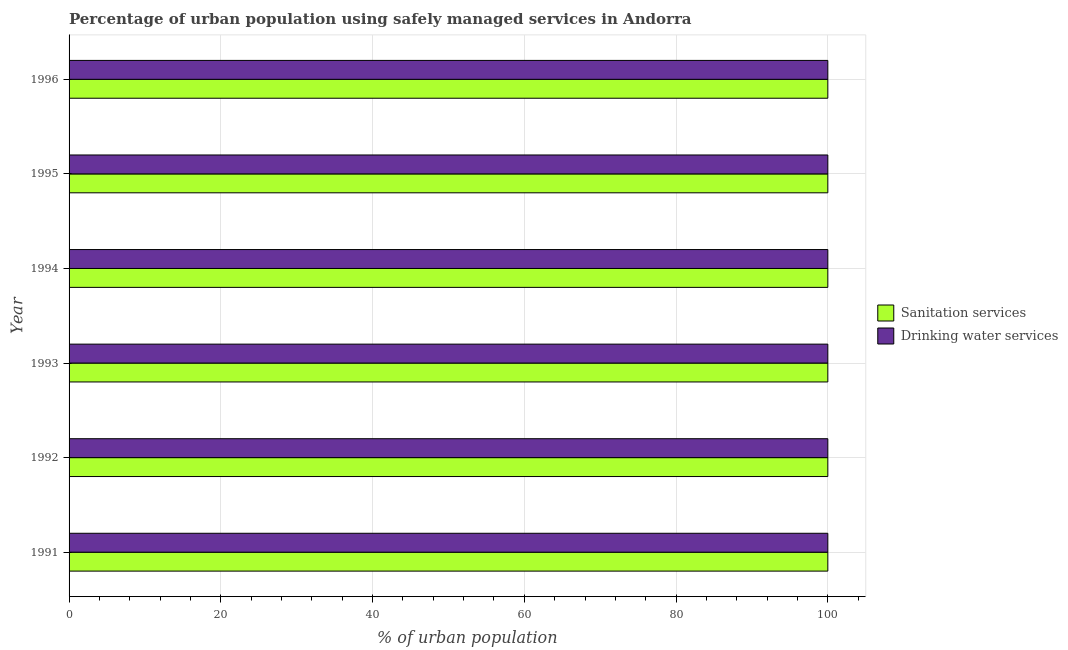How many different coloured bars are there?
Provide a succinct answer. 2. Are the number of bars per tick equal to the number of legend labels?
Provide a short and direct response. Yes. What is the percentage of urban population who used drinking water services in 1996?
Provide a short and direct response. 100. Across all years, what is the maximum percentage of urban population who used sanitation services?
Your answer should be compact. 100. Across all years, what is the minimum percentage of urban population who used sanitation services?
Keep it short and to the point. 100. What is the total percentage of urban population who used drinking water services in the graph?
Offer a very short reply. 600. What is the difference between the percentage of urban population who used drinking water services in 1994 and the percentage of urban population who used sanitation services in 1991?
Provide a short and direct response. 0. In how many years, is the percentage of urban population who used sanitation services greater than 76 %?
Make the answer very short. 6. Is the percentage of urban population who used sanitation services in 1991 less than that in 1994?
Your response must be concise. No. What is the difference between the highest and the second highest percentage of urban population who used drinking water services?
Give a very brief answer. 0. What is the difference between the highest and the lowest percentage of urban population who used sanitation services?
Offer a very short reply. 0. In how many years, is the percentage of urban population who used sanitation services greater than the average percentage of urban population who used sanitation services taken over all years?
Your answer should be compact. 0. Is the sum of the percentage of urban population who used drinking water services in 1992 and 1995 greater than the maximum percentage of urban population who used sanitation services across all years?
Keep it short and to the point. Yes. What does the 2nd bar from the top in 1993 represents?
Your answer should be very brief. Sanitation services. What does the 1st bar from the bottom in 1991 represents?
Keep it short and to the point. Sanitation services. How many bars are there?
Your answer should be compact. 12. Are all the bars in the graph horizontal?
Give a very brief answer. Yes. How many years are there in the graph?
Keep it short and to the point. 6. What is the difference between two consecutive major ticks on the X-axis?
Make the answer very short. 20. Does the graph contain grids?
Offer a terse response. Yes. How are the legend labels stacked?
Your answer should be compact. Vertical. What is the title of the graph?
Keep it short and to the point. Percentage of urban population using safely managed services in Andorra. Does "ODA received" appear as one of the legend labels in the graph?
Make the answer very short. No. What is the label or title of the X-axis?
Keep it short and to the point. % of urban population. What is the % of urban population in Sanitation services in 1992?
Offer a very short reply. 100. What is the % of urban population of Drinking water services in 1992?
Make the answer very short. 100. What is the % of urban population of Drinking water services in 1993?
Keep it short and to the point. 100. What is the % of urban population in Drinking water services in 1994?
Offer a terse response. 100. What is the % of urban population of Sanitation services in 1995?
Make the answer very short. 100. What is the % of urban population of Sanitation services in 1996?
Provide a succinct answer. 100. What is the % of urban population of Drinking water services in 1996?
Offer a very short reply. 100. Across all years, what is the maximum % of urban population in Sanitation services?
Make the answer very short. 100. Across all years, what is the maximum % of urban population of Drinking water services?
Keep it short and to the point. 100. What is the total % of urban population in Sanitation services in the graph?
Make the answer very short. 600. What is the total % of urban population of Drinking water services in the graph?
Your answer should be very brief. 600. What is the difference between the % of urban population of Sanitation services in 1991 and that in 1992?
Provide a short and direct response. 0. What is the difference between the % of urban population of Drinking water services in 1991 and that in 1992?
Provide a succinct answer. 0. What is the difference between the % of urban population in Sanitation services in 1991 and that in 1995?
Your response must be concise. 0. What is the difference between the % of urban population in Drinking water services in 1991 and that in 1995?
Offer a terse response. 0. What is the difference between the % of urban population in Drinking water services in 1991 and that in 1996?
Your response must be concise. 0. What is the difference between the % of urban population of Sanitation services in 1992 and that in 1994?
Your answer should be very brief. 0. What is the difference between the % of urban population of Drinking water services in 1992 and that in 1994?
Provide a short and direct response. 0. What is the difference between the % of urban population in Drinking water services in 1992 and that in 1995?
Ensure brevity in your answer.  0. What is the difference between the % of urban population of Drinking water services in 1993 and that in 1994?
Keep it short and to the point. 0. What is the difference between the % of urban population in Sanitation services in 1993 and that in 1995?
Your answer should be compact. 0. What is the difference between the % of urban population of Drinking water services in 1993 and that in 1995?
Your answer should be very brief. 0. What is the difference between the % of urban population in Sanitation services in 1993 and that in 1996?
Provide a succinct answer. 0. What is the difference between the % of urban population of Drinking water services in 1993 and that in 1996?
Provide a succinct answer. 0. What is the difference between the % of urban population in Sanitation services in 1994 and that in 1995?
Your answer should be compact. 0. What is the difference between the % of urban population in Sanitation services in 1995 and that in 1996?
Offer a terse response. 0. What is the difference between the % of urban population of Sanitation services in 1991 and the % of urban population of Drinking water services in 1992?
Your response must be concise. 0. What is the difference between the % of urban population in Sanitation services in 1991 and the % of urban population in Drinking water services in 1995?
Ensure brevity in your answer.  0. What is the difference between the % of urban population of Sanitation services in 1992 and the % of urban population of Drinking water services in 1994?
Make the answer very short. 0. What is the difference between the % of urban population in Sanitation services in 1992 and the % of urban population in Drinking water services in 1995?
Provide a short and direct response. 0. What is the difference between the % of urban population in Sanitation services in 1993 and the % of urban population in Drinking water services in 1994?
Keep it short and to the point. 0. What is the difference between the % of urban population in Sanitation services in 1994 and the % of urban population in Drinking water services in 1995?
Ensure brevity in your answer.  0. What is the average % of urban population of Sanitation services per year?
Your answer should be very brief. 100. What is the average % of urban population in Drinking water services per year?
Offer a terse response. 100. In the year 1991, what is the difference between the % of urban population in Sanitation services and % of urban population in Drinking water services?
Make the answer very short. 0. In the year 1994, what is the difference between the % of urban population of Sanitation services and % of urban population of Drinking water services?
Keep it short and to the point. 0. What is the ratio of the % of urban population of Sanitation services in 1991 to that in 1992?
Give a very brief answer. 1. What is the ratio of the % of urban population of Sanitation services in 1991 to that in 1993?
Your answer should be very brief. 1. What is the ratio of the % of urban population of Drinking water services in 1991 to that in 1993?
Ensure brevity in your answer.  1. What is the ratio of the % of urban population of Sanitation services in 1991 to that in 1994?
Ensure brevity in your answer.  1. What is the ratio of the % of urban population in Sanitation services in 1991 to that in 1996?
Provide a succinct answer. 1. What is the ratio of the % of urban population in Sanitation services in 1992 to that in 1993?
Make the answer very short. 1. What is the ratio of the % of urban population in Sanitation services in 1992 to that in 1994?
Keep it short and to the point. 1. What is the ratio of the % of urban population of Sanitation services in 1992 to that in 1995?
Provide a succinct answer. 1. What is the ratio of the % of urban population in Sanitation services in 1992 to that in 1996?
Provide a succinct answer. 1. What is the ratio of the % of urban population of Sanitation services in 1993 to that in 1994?
Your answer should be compact. 1. What is the ratio of the % of urban population in Drinking water services in 1993 to that in 1994?
Keep it short and to the point. 1. What is the ratio of the % of urban population in Drinking water services in 1993 to that in 1996?
Ensure brevity in your answer.  1. What is the ratio of the % of urban population of Sanitation services in 1994 to that in 1996?
Provide a short and direct response. 1. What is the ratio of the % of urban population in Drinking water services in 1994 to that in 1996?
Offer a very short reply. 1. What is the difference between the highest and the second highest % of urban population of Sanitation services?
Offer a terse response. 0. What is the difference between the highest and the second highest % of urban population of Drinking water services?
Give a very brief answer. 0. What is the difference between the highest and the lowest % of urban population of Sanitation services?
Your answer should be compact. 0. 